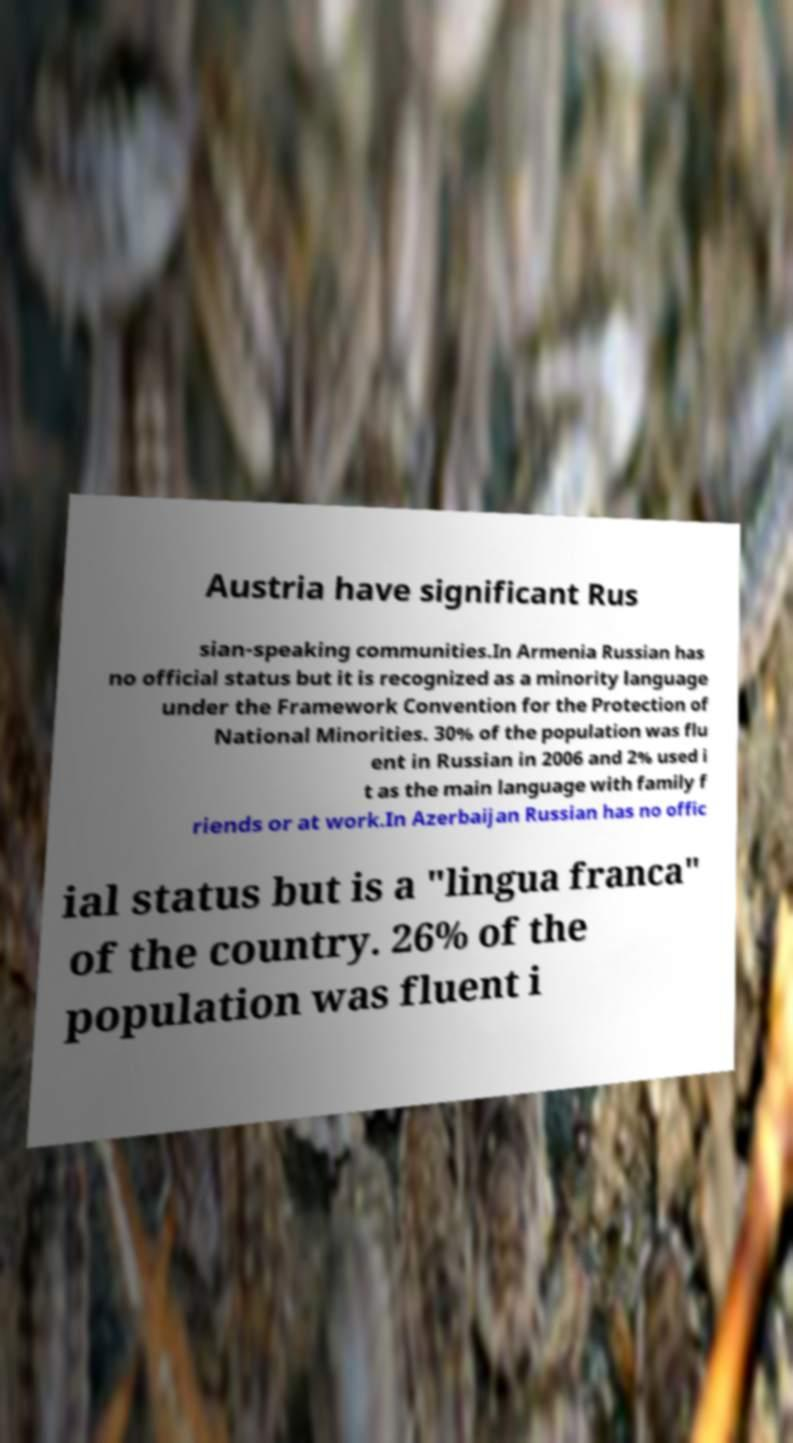Can you accurately transcribe the text from the provided image for me? Austria have significant Rus sian-speaking communities.In Armenia Russian has no official status but it is recognized as a minority language under the Framework Convention for the Protection of National Minorities. 30% of the population was flu ent in Russian in 2006 and 2% used i t as the main language with family f riends or at work.In Azerbaijan Russian has no offic ial status but is a "lingua franca" of the country. 26% of the population was fluent i 